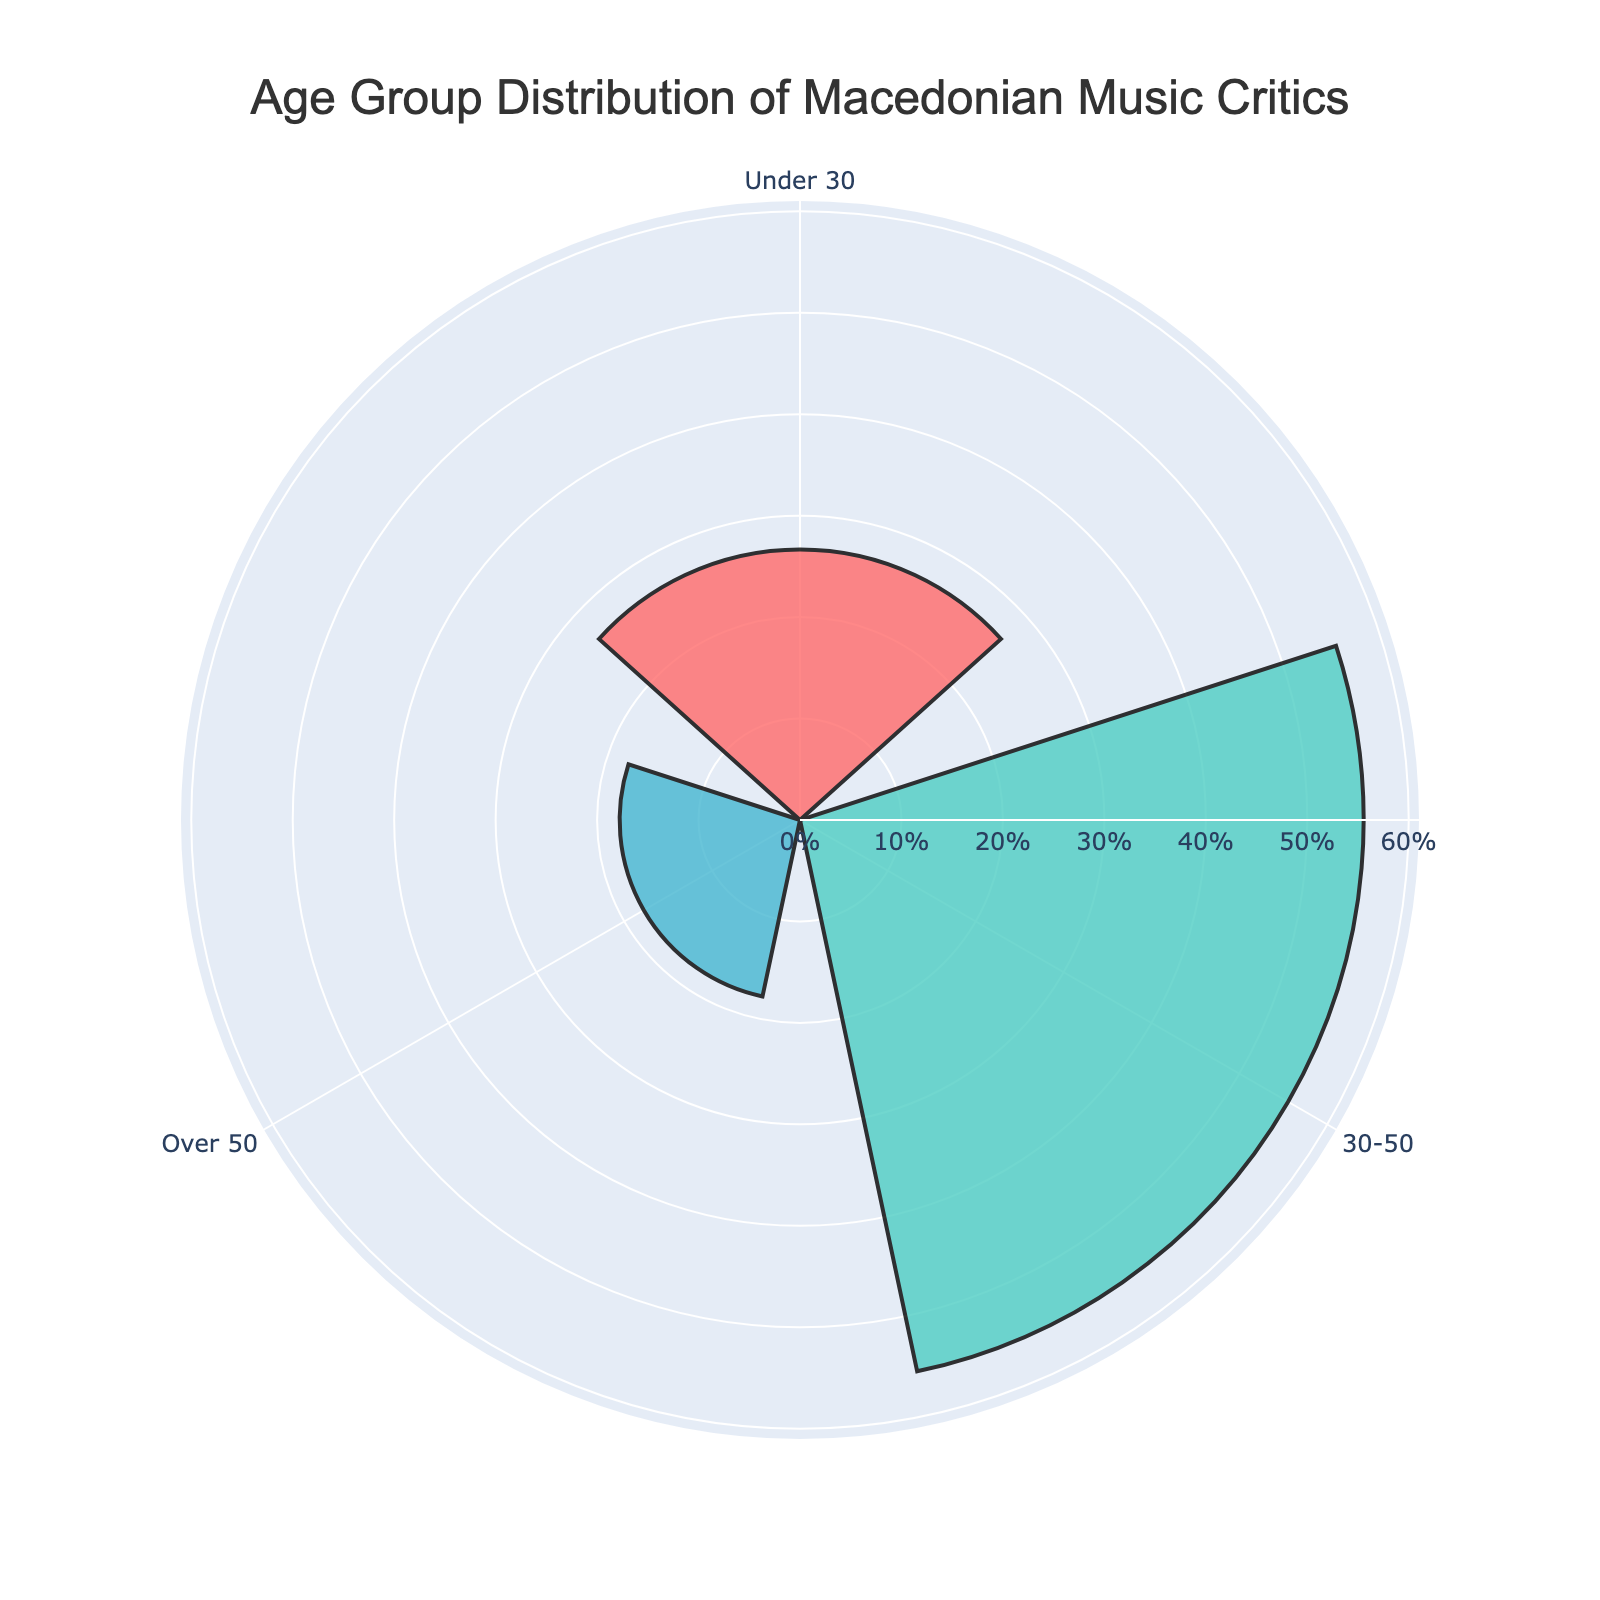what are the three age groups listed in the chart? The chart lists the following age groups: Under 30, 30-50, and Over 50. These groups are distributed around the rose chart and can be identified by the labels at corresponding angles.
Answer: Under 30, 30-50, Over 50 what is the title of the chart? The title of the chart is located at the top and it reads "Age Group Distribution of Macedonian Music Critics".
Answer: Age Group Distribution of Macedonian Music Critics which age group has the smallest percentage representation? By looking at the length of the bars radiating outward, the age group "Over 50" has the shortest bar, indicating the smallest percentage.
Answer: Over 50 what percentage of Macedonian music critics are aged Under 30? The bar representing the "Under 30" age group extends to around 32.4%, as indicated in the visual.
Answer: 32.4% how many more critics are there in the 30-50 age group compared to the Over 50 age group? The chart indicates 25 critics in the 30-50 age group and 8 in the Over 50 group. Subtracting 8 from 25 gives the difference.
Answer: 17 what is the combined percentage of critics aged Under 30 and Over 50? The Under 30 group is 32.4% and the Over 50 group is 21.6%. Adding these percentages together gives the total combined percentage.
Answer: 54% which age group forms the majority among the Macedonian music critics? The 30-50 age group has the largest bar, indicating the majority with 48%.
Answer: 30-50 if you were to divide the critics into two groups, one below 50 and one above 50, what would be the approximate percentage representation of each? The groups are Under 30 (32.4%) + 30-50 (48%) = 80.4% below 50, and Over 50 (21.6%) as above 50.
Answer: 80.4% below 50, 21.6% above 50 how does the percentage of the 30-50 age group compare to the sum of the other two age groups? The 30-50 group is 48%. The combined percentage of Under 30 and Over 50 is 32.4% + 21.6% = 54%. Thus, the 30-50 group is slightly less than the sum of the other two groups.
Answer: 48% is slightly less than 54% 